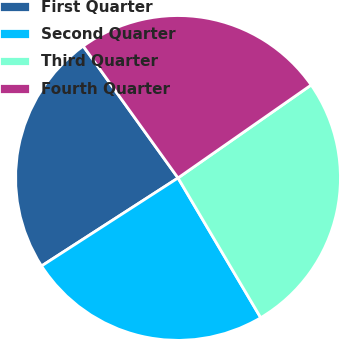<chart> <loc_0><loc_0><loc_500><loc_500><pie_chart><fcel>First Quarter<fcel>Second Quarter<fcel>Third Quarter<fcel>Fourth Quarter<nl><fcel>24.2%<fcel>24.39%<fcel>26.2%<fcel>25.22%<nl></chart> 